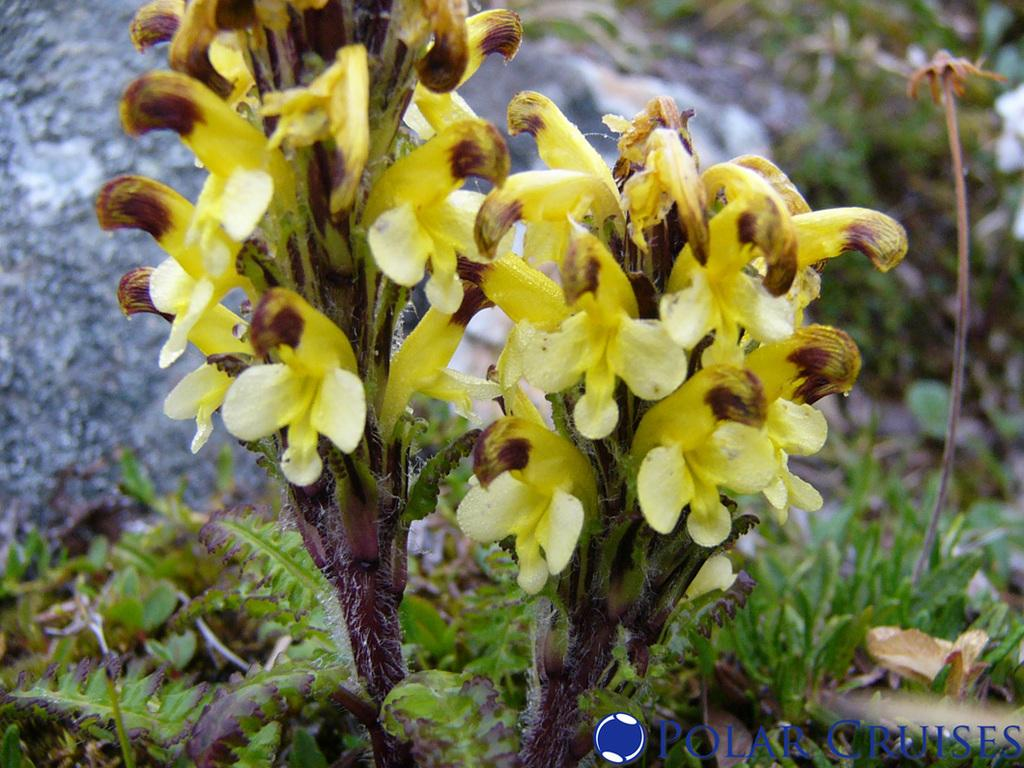What can be seen in the foreground of the image? There are flowers and plants in the foreground of the image. What can be observed about the background of the image? The background of the image is not clear. What type of vegetation is visible in the background of the image? There is greenery visible in the background of the image. What else can be seen in the background of the image besides greenery? There are other objects present in the background of the image. What type of dolls are present in the image, and how do they feel about the shame they are experiencing? There are no dolls or any indication of shame present in the image. 